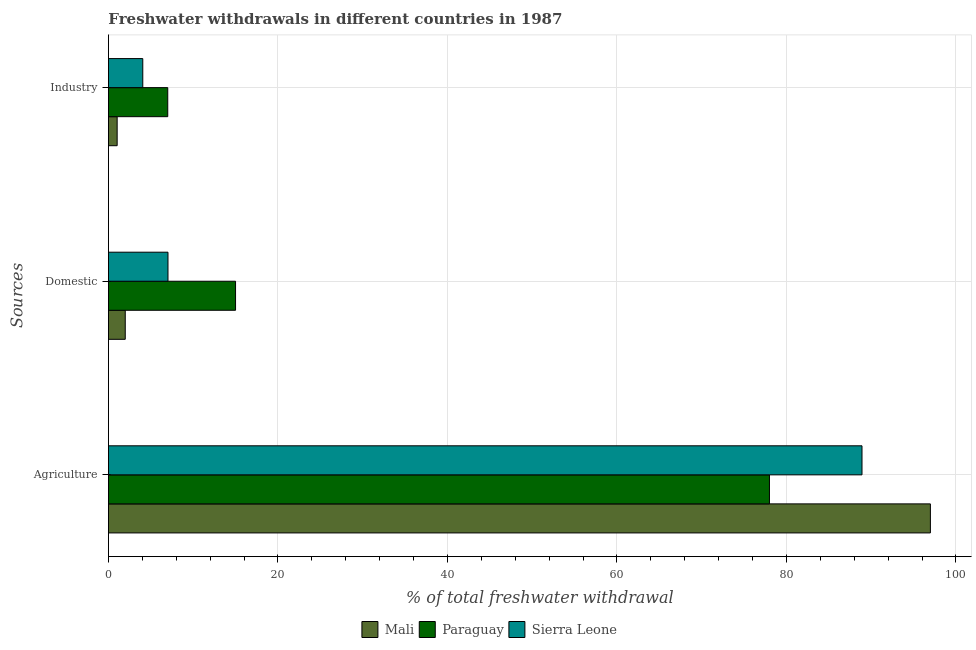How many different coloured bars are there?
Give a very brief answer. 3. Are the number of bars on each tick of the Y-axis equal?
Offer a terse response. Yes. How many bars are there on the 1st tick from the top?
Ensure brevity in your answer.  3. What is the label of the 3rd group of bars from the top?
Offer a very short reply. Agriculture. What is the percentage of freshwater withdrawal for agriculture in Sierra Leone?
Your answer should be compact. 88.92. Across all countries, what is the maximum percentage of freshwater withdrawal for agriculture?
Give a very brief answer. 96.99. In which country was the percentage of freshwater withdrawal for agriculture maximum?
Your answer should be very brief. Mali. In which country was the percentage of freshwater withdrawal for industry minimum?
Your response must be concise. Mali. What is the total percentage of freshwater withdrawal for agriculture in the graph?
Your answer should be very brief. 263.91. What is the difference between the percentage of freshwater withdrawal for domestic purposes in Sierra Leone and that in Paraguay?
Keep it short and to the point. -7.97. What is the difference between the percentage of freshwater withdrawal for agriculture in Sierra Leone and the percentage of freshwater withdrawal for industry in Mali?
Your answer should be compact. 87.89. What is the average percentage of freshwater withdrawal for industry per country?
Provide a succinct answer. 4.03. In how many countries, is the percentage of freshwater withdrawal for domestic purposes greater than 8 %?
Provide a succinct answer. 1. What is the ratio of the percentage of freshwater withdrawal for domestic purposes in Paraguay to that in Mali?
Offer a terse response. 7.56. Is the percentage of freshwater withdrawal for domestic purposes in Paraguay less than that in Sierra Leone?
Keep it short and to the point. No. Is the difference between the percentage of freshwater withdrawal for domestic purposes in Sierra Leone and Paraguay greater than the difference between the percentage of freshwater withdrawal for industry in Sierra Leone and Paraguay?
Provide a succinct answer. No. What is the difference between the highest and the second highest percentage of freshwater withdrawal for agriculture?
Your response must be concise. 8.07. What is the difference between the highest and the lowest percentage of freshwater withdrawal for agriculture?
Your response must be concise. 18.99. In how many countries, is the percentage of freshwater withdrawal for domestic purposes greater than the average percentage of freshwater withdrawal for domestic purposes taken over all countries?
Offer a very short reply. 1. What does the 2nd bar from the top in Industry represents?
Offer a very short reply. Paraguay. What does the 3rd bar from the bottom in Domestic represents?
Ensure brevity in your answer.  Sierra Leone. Is it the case that in every country, the sum of the percentage of freshwater withdrawal for agriculture and percentage of freshwater withdrawal for domestic purposes is greater than the percentage of freshwater withdrawal for industry?
Your answer should be compact. Yes. Are all the bars in the graph horizontal?
Make the answer very short. Yes. What is the difference between two consecutive major ticks on the X-axis?
Your response must be concise. 20. Are the values on the major ticks of X-axis written in scientific E-notation?
Keep it short and to the point. No. Does the graph contain any zero values?
Ensure brevity in your answer.  No. Does the graph contain grids?
Ensure brevity in your answer.  Yes. How many legend labels are there?
Ensure brevity in your answer.  3. How are the legend labels stacked?
Make the answer very short. Horizontal. What is the title of the graph?
Offer a very short reply. Freshwater withdrawals in different countries in 1987. Does "Jamaica" appear as one of the legend labels in the graph?
Keep it short and to the point. No. What is the label or title of the X-axis?
Your answer should be very brief. % of total freshwater withdrawal. What is the label or title of the Y-axis?
Ensure brevity in your answer.  Sources. What is the % of total freshwater withdrawal of Mali in Agriculture?
Make the answer very short. 96.99. What is the % of total freshwater withdrawal of Sierra Leone in Agriculture?
Make the answer very short. 88.92. What is the % of total freshwater withdrawal in Mali in Domestic?
Give a very brief answer. 1.99. What is the % of total freshwater withdrawal in Paraguay in Domestic?
Provide a short and direct response. 15. What is the % of total freshwater withdrawal in Sierra Leone in Domestic?
Provide a short and direct response. 7.03. What is the % of total freshwater withdrawal in Paraguay in Industry?
Provide a short and direct response. 7. What is the % of total freshwater withdrawal of Sierra Leone in Industry?
Make the answer very short. 4.05. Across all Sources, what is the maximum % of total freshwater withdrawal in Mali?
Your response must be concise. 96.99. Across all Sources, what is the maximum % of total freshwater withdrawal in Sierra Leone?
Your response must be concise. 88.92. Across all Sources, what is the minimum % of total freshwater withdrawal of Paraguay?
Provide a succinct answer. 7. Across all Sources, what is the minimum % of total freshwater withdrawal of Sierra Leone?
Your answer should be very brief. 4.05. What is the total % of total freshwater withdrawal in Mali in the graph?
Provide a succinct answer. 100. What is the total % of total freshwater withdrawal in Paraguay in the graph?
Ensure brevity in your answer.  100. What is the total % of total freshwater withdrawal in Sierra Leone in the graph?
Provide a short and direct response. 100. What is the difference between the % of total freshwater withdrawal in Mali in Agriculture and that in Domestic?
Give a very brief answer. 95. What is the difference between the % of total freshwater withdrawal in Paraguay in Agriculture and that in Domestic?
Make the answer very short. 63. What is the difference between the % of total freshwater withdrawal of Sierra Leone in Agriculture and that in Domestic?
Provide a short and direct response. 81.89. What is the difference between the % of total freshwater withdrawal in Mali in Agriculture and that in Industry?
Your response must be concise. 95.96. What is the difference between the % of total freshwater withdrawal of Paraguay in Agriculture and that in Industry?
Your response must be concise. 71. What is the difference between the % of total freshwater withdrawal of Sierra Leone in Agriculture and that in Industry?
Give a very brief answer. 84.87. What is the difference between the % of total freshwater withdrawal of Mali in Domestic and that in Industry?
Make the answer very short. 0.96. What is the difference between the % of total freshwater withdrawal in Paraguay in Domestic and that in Industry?
Your answer should be very brief. 8. What is the difference between the % of total freshwater withdrawal of Sierra Leone in Domestic and that in Industry?
Provide a short and direct response. 2.97. What is the difference between the % of total freshwater withdrawal of Mali in Agriculture and the % of total freshwater withdrawal of Paraguay in Domestic?
Make the answer very short. 81.99. What is the difference between the % of total freshwater withdrawal of Mali in Agriculture and the % of total freshwater withdrawal of Sierra Leone in Domestic?
Offer a very short reply. 89.96. What is the difference between the % of total freshwater withdrawal in Paraguay in Agriculture and the % of total freshwater withdrawal in Sierra Leone in Domestic?
Make the answer very short. 70.97. What is the difference between the % of total freshwater withdrawal of Mali in Agriculture and the % of total freshwater withdrawal of Paraguay in Industry?
Your answer should be compact. 89.99. What is the difference between the % of total freshwater withdrawal of Mali in Agriculture and the % of total freshwater withdrawal of Sierra Leone in Industry?
Make the answer very short. 92.94. What is the difference between the % of total freshwater withdrawal in Paraguay in Agriculture and the % of total freshwater withdrawal in Sierra Leone in Industry?
Keep it short and to the point. 73.95. What is the difference between the % of total freshwater withdrawal in Mali in Domestic and the % of total freshwater withdrawal in Paraguay in Industry?
Your answer should be compact. -5.01. What is the difference between the % of total freshwater withdrawal of Mali in Domestic and the % of total freshwater withdrawal of Sierra Leone in Industry?
Offer a terse response. -2.07. What is the difference between the % of total freshwater withdrawal of Paraguay in Domestic and the % of total freshwater withdrawal of Sierra Leone in Industry?
Keep it short and to the point. 10.95. What is the average % of total freshwater withdrawal of Mali per Sources?
Make the answer very short. 33.33. What is the average % of total freshwater withdrawal in Paraguay per Sources?
Offer a very short reply. 33.33. What is the average % of total freshwater withdrawal in Sierra Leone per Sources?
Your answer should be very brief. 33.33. What is the difference between the % of total freshwater withdrawal of Mali and % of total freshwater withdrawal of Paraguay in Agriculture?
Provide a short and direct response. 18.99. What is the difference between the % of total freshwater withdrawal in Mali and % of total freshwater withdrawal in Sierra Leone in Agriculture?
Your answer should be compact. 8.07. What is the difference between the % of total freshwater withdrawal of Paraguay and % of total freshwater withdrawal of Sierra Leone in Agriculture?
Your answer should be very brief. -10.92. What is the difference between the % of total freshwater withdrawal of Mali and % of total freshwater withdrawal of Paraguay in Domestic?
Provide a succinct answer. -13.02. What is the difference between the % of total freshwater withdrawal of Mali and % of total freshwater withdrawal of Sierra Leone in Domestic?
Provide a succinct answer. -5.04. What is the difference between the % of total freshwater withdrawal of Paraguay and % of total freshwater withdrawal of Sierra Leone in Domestic?
Offer a very short reply. 7.97. What is the difference between the % of total freshwater withdrawal in Mali and % of total freshwater withdrawal in Paraguay in Industry?
Ensure brevity in your answer.  -5.97. What is the difference between the % of total freshwater withdrawal of Mali and % of total freshwater withdrawal of Sierra Leone in Industry?
Give a very brief answer. -3.02. What is the difference between the % of total freshwater withdrawal in Paraguay and % of total freshwater withdrawal in Sierra Leone in Industry?
Give a very brief answer. 2.95. What is the ratio of the % of total freshwater withdrawal in Mali in Agriculture to that in Domestic?
Give a very brief answer. 48.86. What is the ratio of the % of total freshwater withdrawal of Paraguay in Agriculture to that in Domestic?
Your answer should be very brief. 5.2. What is the ratio of the % of total freshwater withdrawal in Sierra Leone in Agriculture to that in Domestic?
Your response must be concise. 12.65. What is the ratio of the % of total freshwater withdrawal of Mali in Agriculture to that in Industry?
Make the answer very short. 94.26. What is the ratio of the % of total freshwater withdrawal of Paraguay in Agriculture to that in Industry?
Your answer should be compact. 11.14. What is the ratio of the % of total freshwater withdrawal of Sierra Leone in Agriculture to that in Industry?
Your answer should be very brief. 21.93. What is the ratio of the % of total freshwater withdrawal of Mali in Domestic to that in Industry?
Give a very brief answer. 1.93. What is the ratio of the % of total freshwater withdrawal in Paraguay in Domestic to that in Industry?
Your response must be concise. 2.14. What is the ratio of the % of total freshwater withdrawal of Sierra Leone in Domestic to that in Industry?
Give a very brief answer. 1.73. What is the difference between the highest and the second highest % of total freshwater withdrawal in Mali?
Keep it short and to the point. 95. What is the difference between the highest and the second highest % of total freshwater withdrawal in Paraguay?
Your answer should be compact. 63. What is the difference between the highest and the second highest % of total freshwater withdrawal of Sierra Leone?
Ensure brevity in your answer.  81.89. What is the difference between the highest and the lowest % of total freshwater withdrawal of Mali?
Ensure brevity in your answer.  95.96. What is the difference between the highest and the lowest % of total freshwater withdrawal in Sierra Leone?
Provide a succinct answer. 84.87. 